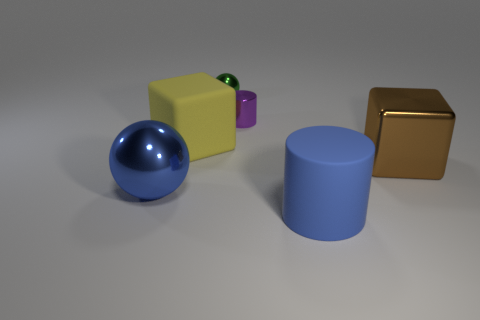What material is the cylinder that is the same color as the big metal sphere?
Ensure brevity in your answer.  Rubber. Is the number of big gray things greater than the number of tiny objects?
Your response must be concise. No. How many other things are the same material as the brown block?
Provide a succinct answer. 3. There is a blue thing that is on the left side of the block that is behind the big thing to the right of the large blue matte object; what is its shape?
Offer a terse response. Sphere. Are there fewer large blue matte objects that are on the left side of the blue shiny object than purple metallic cylinders behind the tiny green shiny ball?
Give a very brief answer. No. Is there a thing that has the same color as the small metallic cylinder?
Ensure brevity in your answer.  No. Are the tiny cylinder and the small object that is behind the purple metal thing made of the same material?
Ensure brevity in your answer.  Yes. Are there any small green things that are to the right of the large rubber object on the right side of the big yellow cube?
Give a very brief answer. No. The big object that is to the right of the tiny green sphere and behind the big blue shiny thing is what color?
Your answer should be compact. Brown. How big is the matte cube?
Offer a very short reply. Large. 